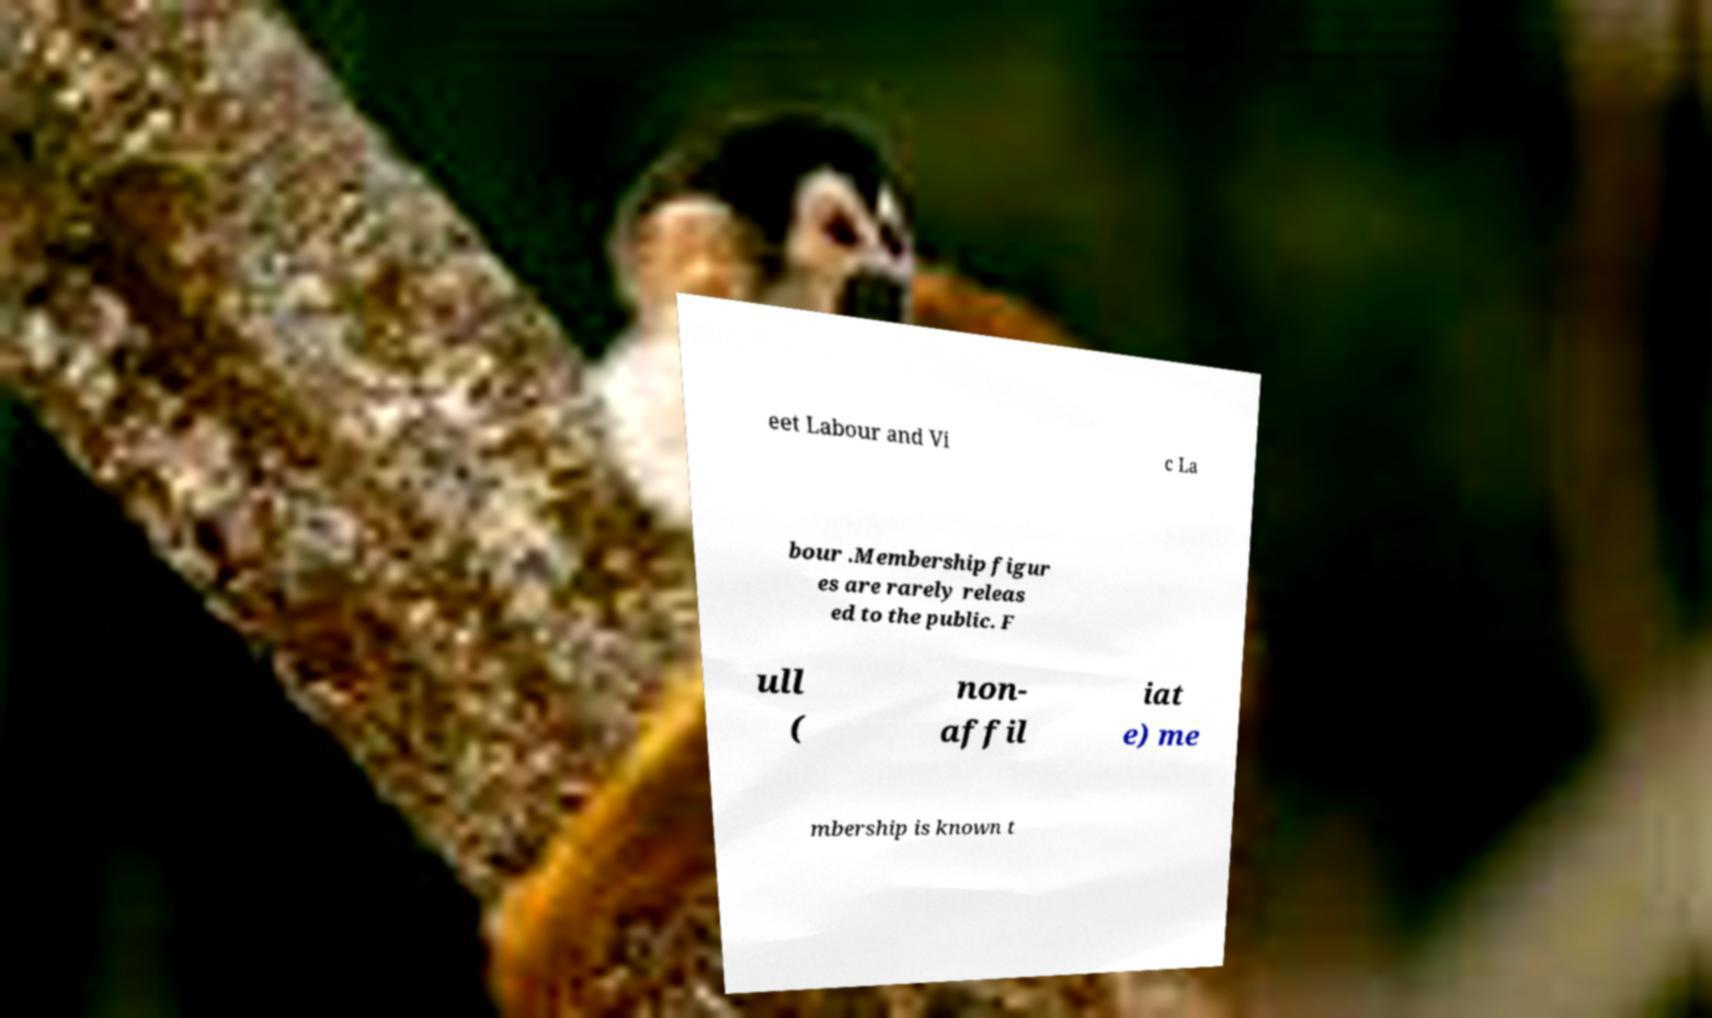Please identify and transcribe the text found in this image. eet Labour and Vi c La bour .Membership figur es are rarely releas ed to the public. F ull ( non- affil iat e) me mbership is known t 